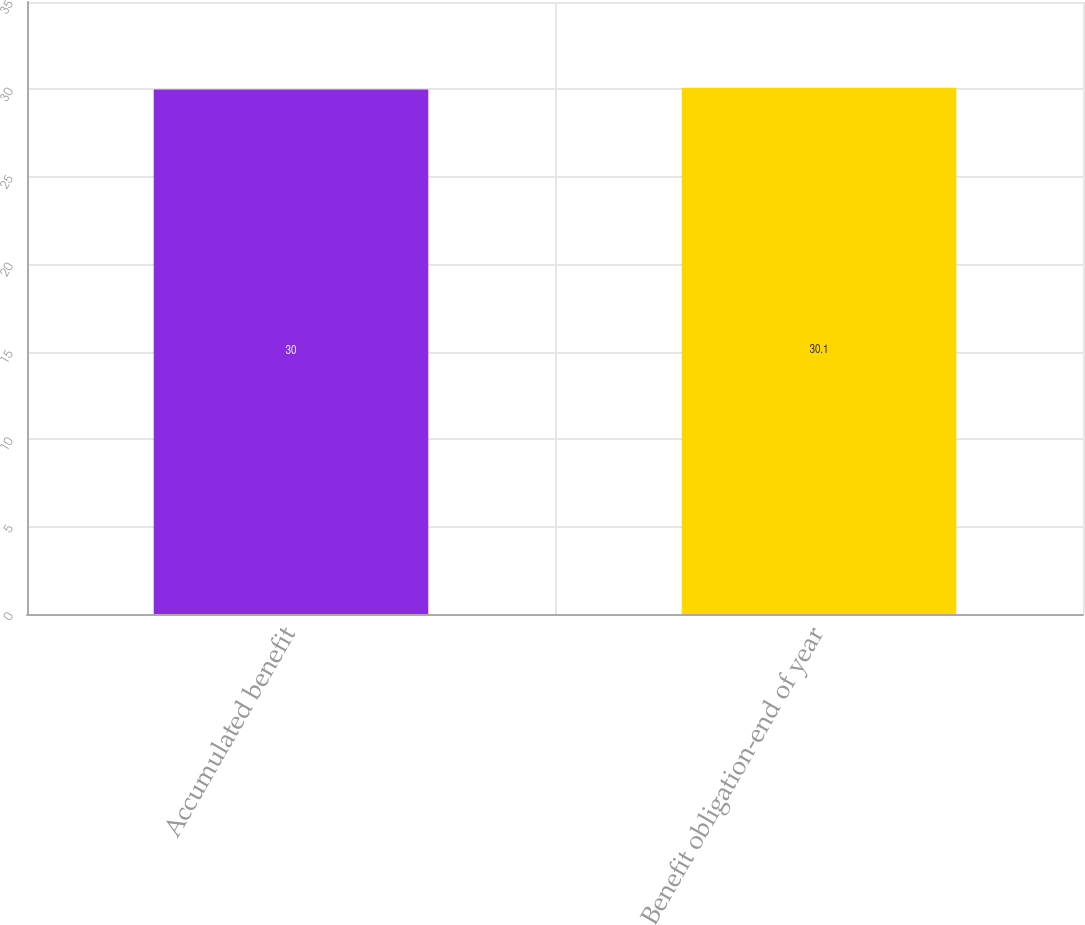<chart> <loc_0><loc_0><loc_500><loc_500><bar_chart><fcel>Accumulated benefit<fcel>Benefit obligation-end of year<nl><fcel>30<fcel>30.1<nl></chart> 